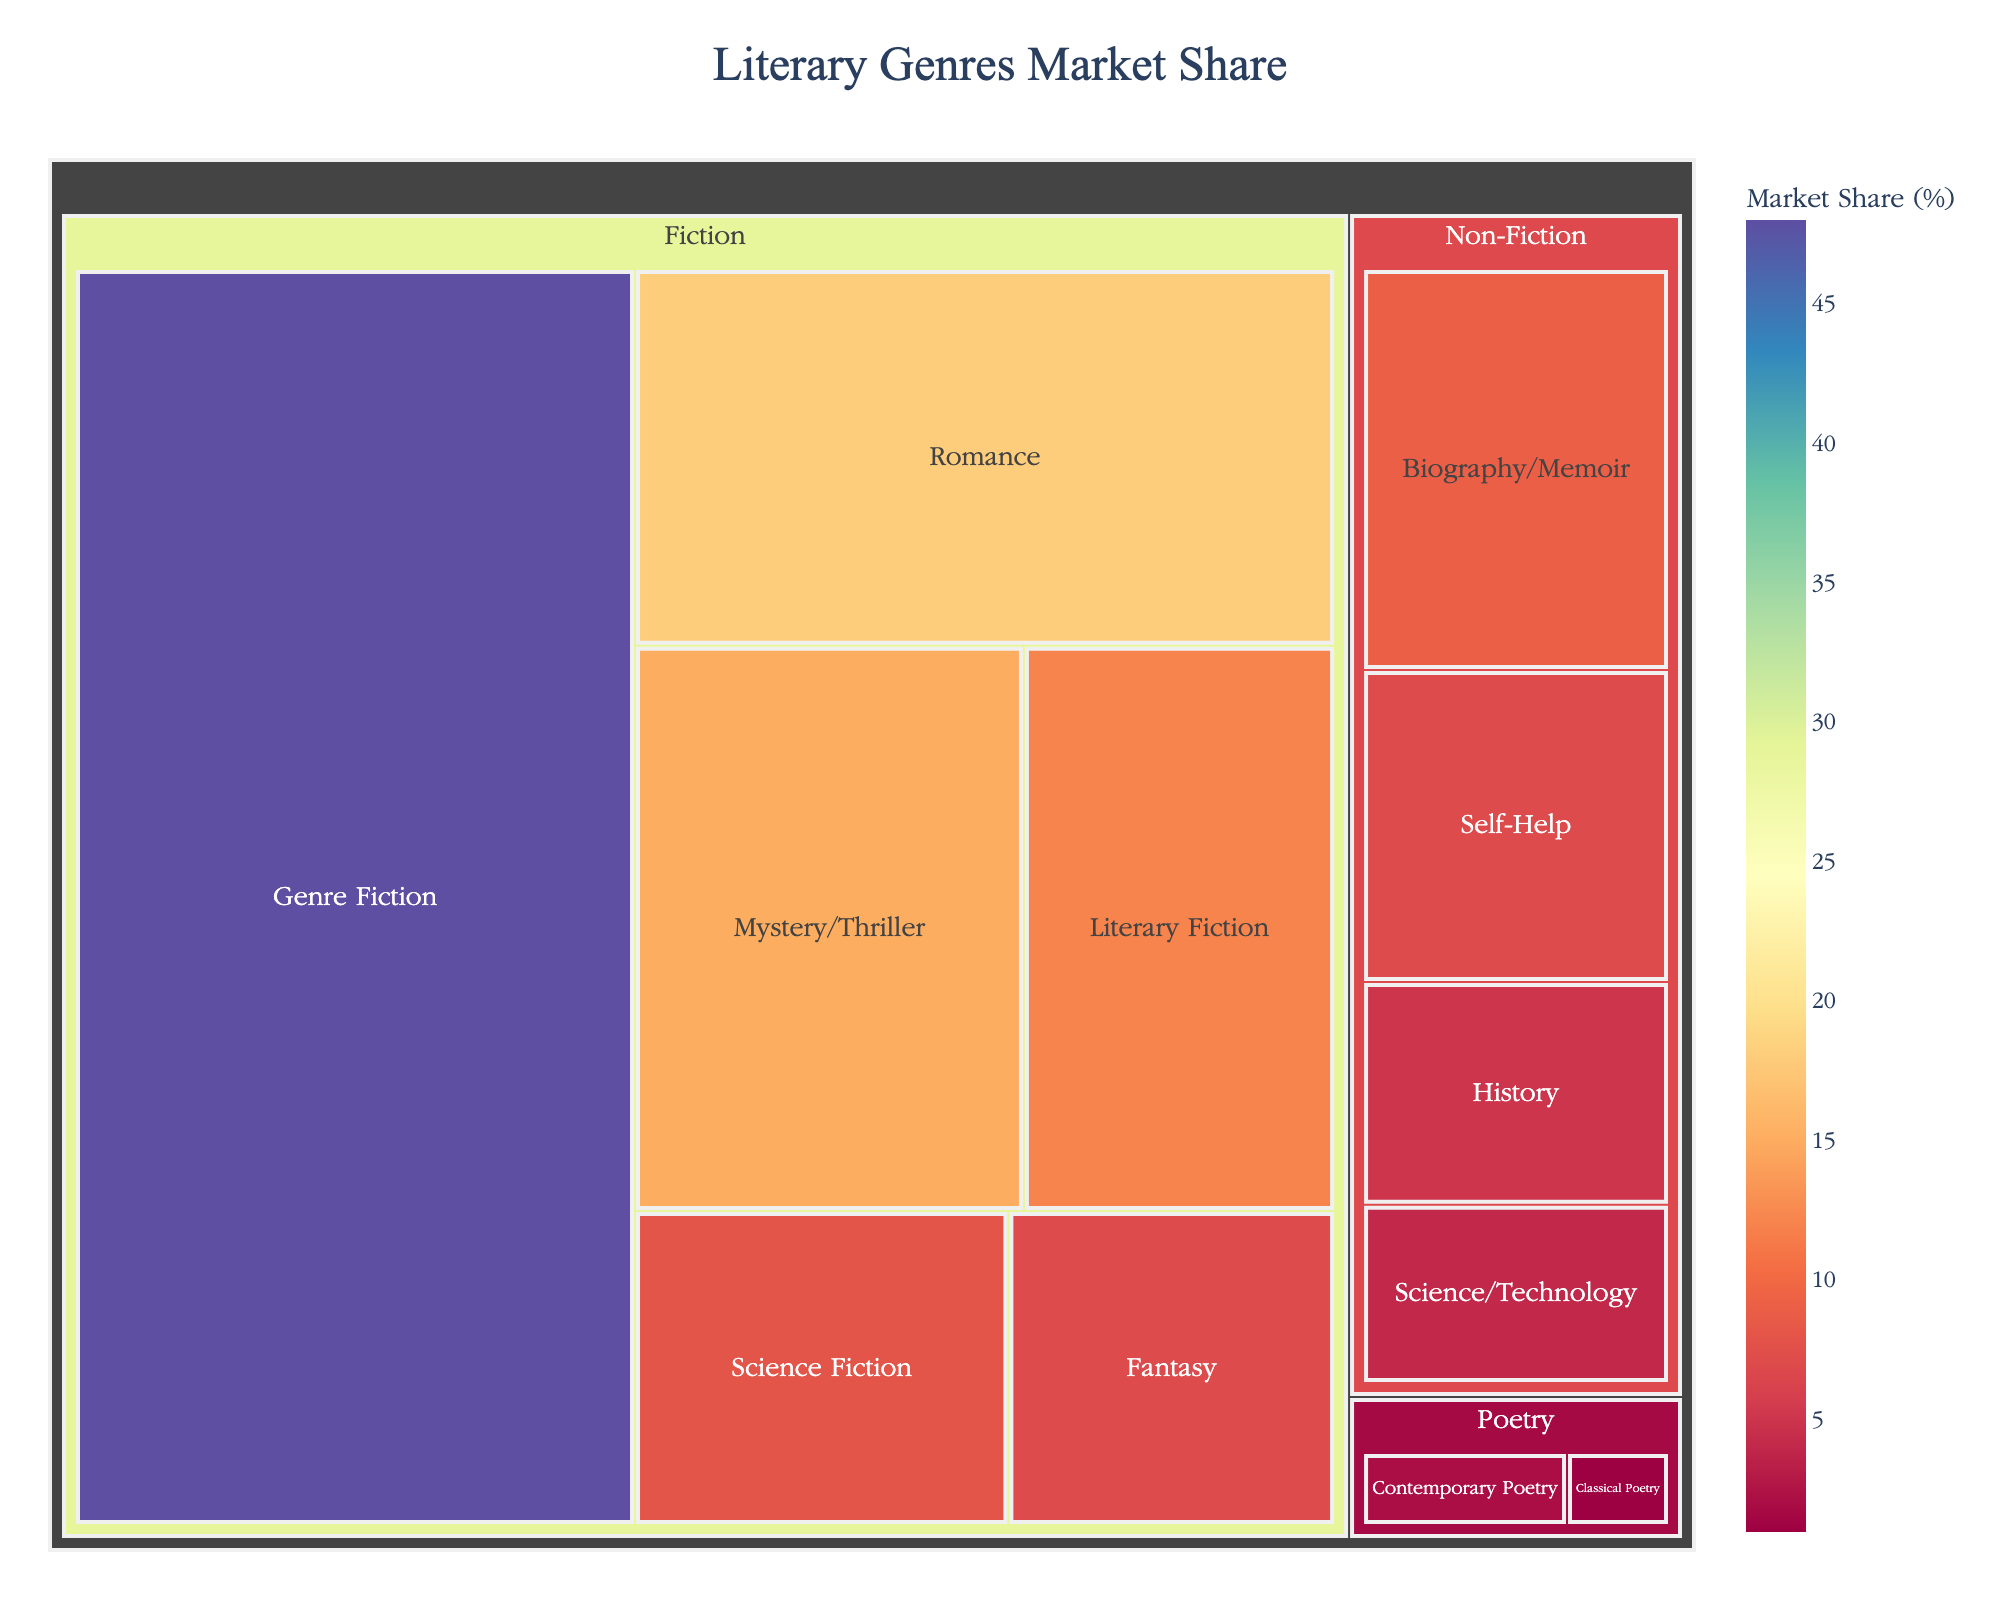What is the market share of Mystery/Thriller within the Fiction category? To find the market share of Mystery/Thriller, locate the Fiction section and identify the share corresponding to Mystery/Thriller.
Answer: 15% Which genre within Fiction has the highest market share? Look at the Fiction category and compare the market shares of all listed genres.
Answer: Genre Fiction What is the combined market share of the Poetry category? Add the market shares of Contemporary Poetry and Classical Poetry. i.e., 2% + 1% = 3%
Answer: 3% How does the market share of Romance compare to Biography/Memoir? Compare the market shares by looking at their values in the Fiction and Non-Fiction categories respectively. Romance: 18%, Biography/Memoir: 9%.
Answer: Romance has double the market share of Biography/Memoir Which category (Fiction, Non-Fiction, or Poetry) has the most diverse genres in the publishing industry? Compare the number of genres listed under each category. Fiction has 6 genres, Non-Fiction has 4, and Poetry has 2.
Answer: Fiction What's the total market share held by Non-Fiction and Poetry combined? Summing up the market shares of all genres under Non-Fiction (9% + 7% + 5% + 4% = 25%) and Poetry (2% + 1% = 3%). Thus, 25% + 3% = 28%.
Answer: 28% Is the market share of Science Fiction higher or lower than that of History? Compare their market shares respectively: Science Fiction (8%) vs. History (5%). Science Fiction is higher.
Answer: Higher What percentage of the Fiction market is not occupied by Literary Fiction or Genre Fiction? Subtract the market shares of Literary Fiction and Genre Fiction from the total Fiction's market share: 100% - (12% + 48%) = 40%.
Answer: 40% Within the Non-Fiction category, which genre has the smallest market share? Among Non-Fiction genres, compare the market shares to find the smallest one. Science/Technology has the smallest share at 4%.
Answer: Science/Technology What is the market share difference between the highest and lowest genres in the overall data? Identify the highest (Genre Fiction at 48%) and the lowest (Classical Poetry at 1%), then subtract their market shares: 48% - 1% = 47%.
Answer: 47% 